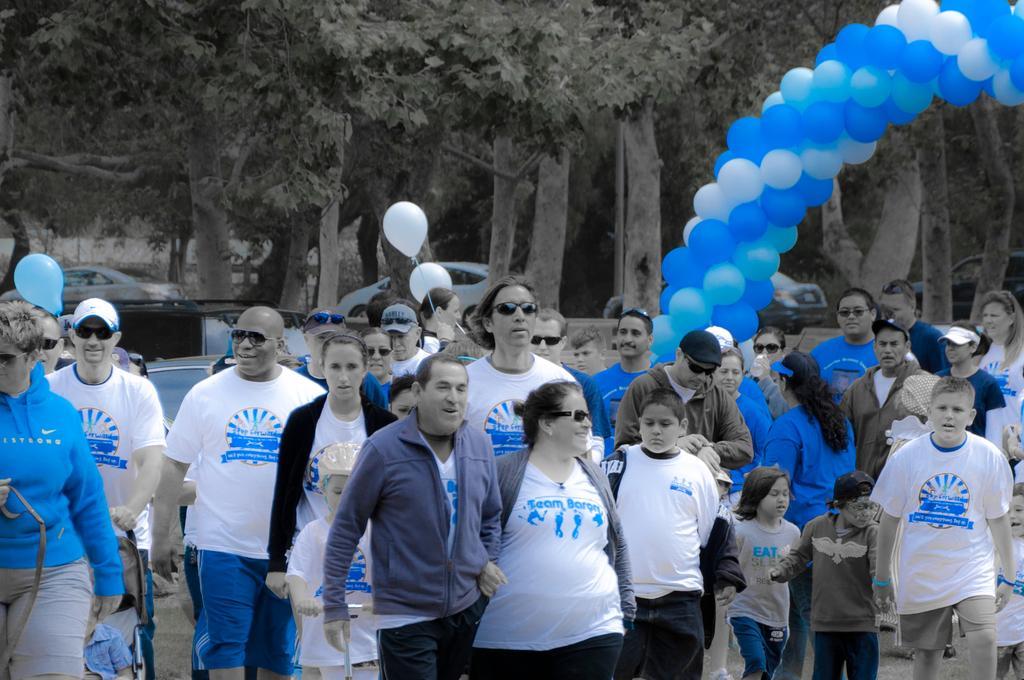Can you describe this image briefly? In this image I can see a crowd on the road. In the background I can see balloons, vehicles on the road and trees. This image is taken during a day. 